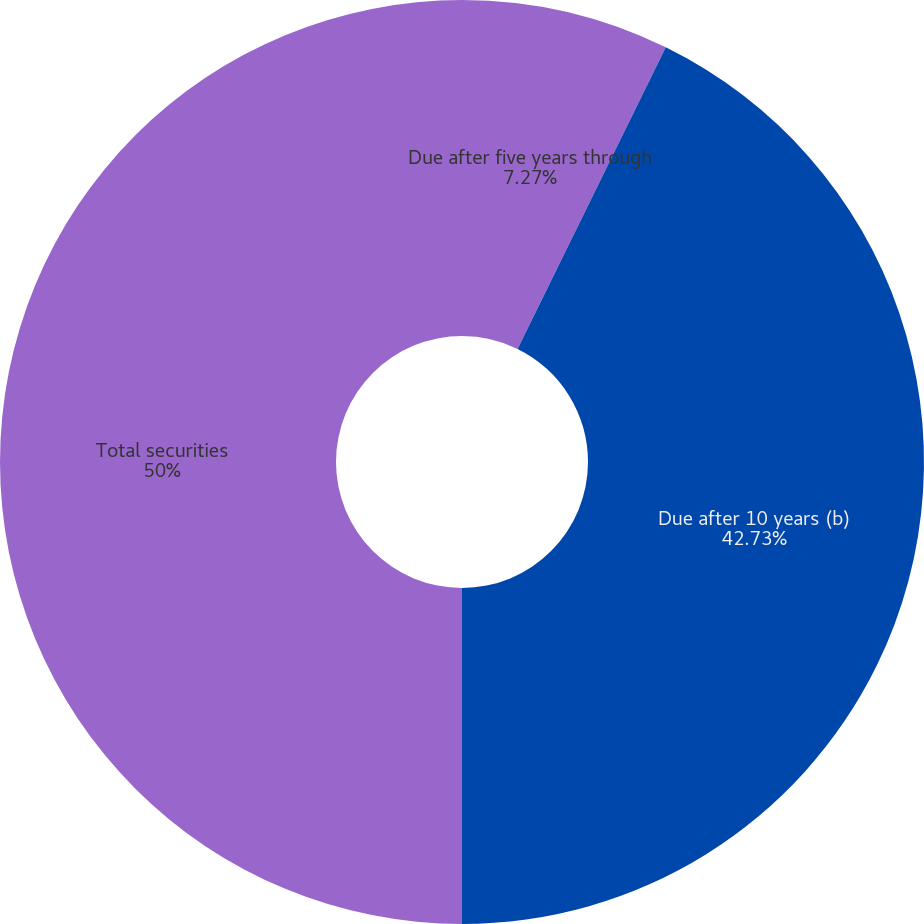Convert chart. <chart><loc_0><loc_0><loc_500><loc_500><pie_chart><fcel>Due after five years through<fcel>Due after 10 years (b)<fcel>Total securities<nl><fcel>7.27%<fcel>42.73%<fcel>50.0%<nl></chart> 